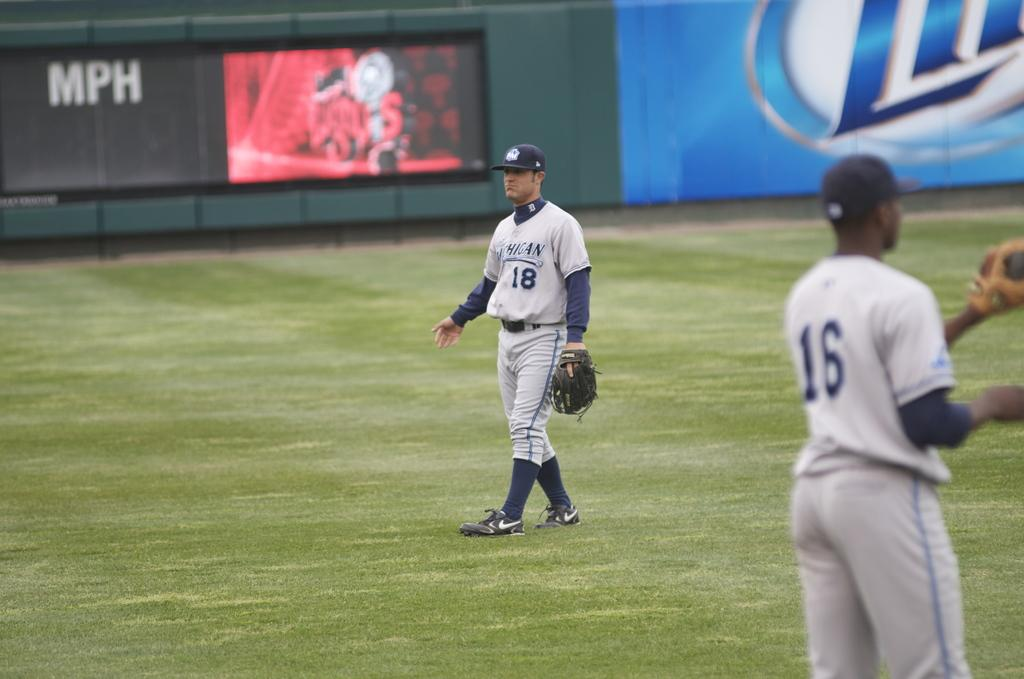<image>
Present a compact description of the photo's key features. Baseball players on a field where there is a sign for MPH 